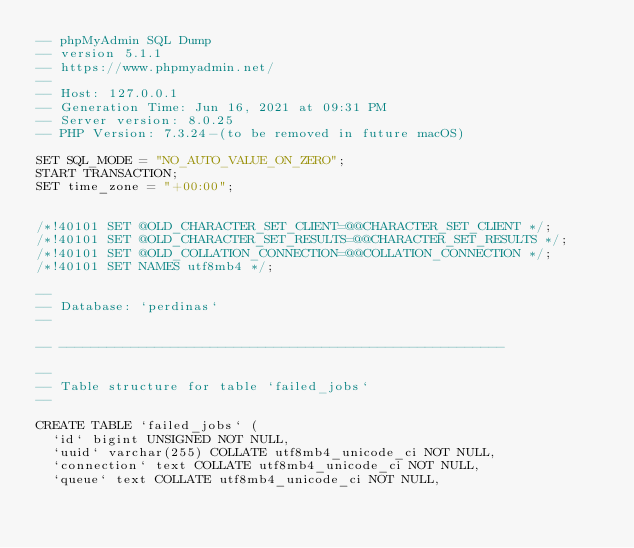<code> <loc_0><loc_0><loc_500><loc_500><_SQL_>-- phpMyAdmin SQL Dump
-- version 5.1.1
-- https://www.phpmyadmin.net/
--
-- Host: 127.0.0.1
-- Generation Time: Jun 16, 2021 at 09:31 PM
-- Server version: 8.0.25
-- PHP Version: 7.3.24-(to be removed in future macOS)

SET SQL_MODE = "NO_AUTO_VALUE_ON_ZERO";
START TRANSACTION;
SET time_zone = "+00:00";


/*!40101 SET @OLD_CHARACTER_SET_CLIENT=@@CHARACTER_SET_CLIENT */;
/*!40101 SET @OLD_CHARACTER_SET_RESULTS=@@CHARACTER_SET_RESULTS */;
/*!40101 SET @OLD_COLLATION_CONNECTION=@@COLLATION_CONNECTION */;
/*!40101 SET NAMES utf8mb4 */;

--
-- Database: `perdinas`
--

-- --------------------------------------------------------

--
-- Table structure for table `failed_jobs`
--

CREATE TABLE `failed_jobs` (
  `id` bigint UNSIGNED NOT NULL,
  `uuid` varchar(255) COLLATE utf8mb4_unicode_ci NOT NULL,
  `connection` text COLLATE utf8mb4_unicode_ci NOT NULL,
  `queue` text COLLATE utf8mb4_unicode_ci NOT NULL,</code> 